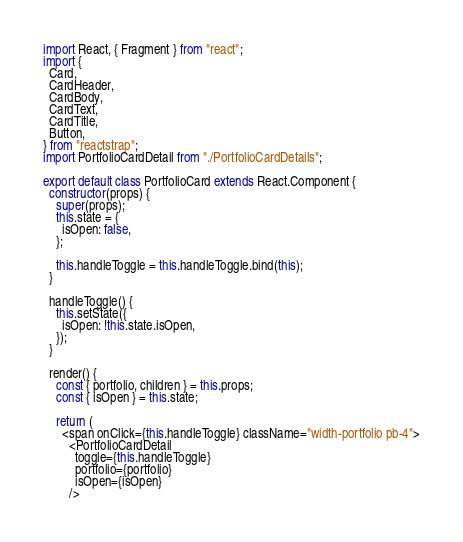<code> <loc_0><loc_0><loc_500><loc_500><_JavaScript_>import React, { Fragment } from "react";
import {
  Card,
  CardHeader,
  CardBody,
  CardText,
  CardTitle,
  Button,
} from "reactstrap";
import PortfolioCardDetail from "./PortfolioCardDetails";

export default class PortfolioCard extends React.Component {
  constructor(props) {
    super(props);
    this.state = {
      isOpen: false,
    };

    this.handleToggle = this.handleToggle.bind(this);
  }

  handleToggle() {
    this.setState({
      isOpen: !this.state.isOpen,
    });
  }

  render() {
    const { portfolio, children } = this.props;
    const { isOpen } = this.state;

    return (
      <span onClick={this.handleToggle} className="width-portfolio pb-4">
        <PortfolioCardDetail
          toggle={this.handleToggle}
          portfolio={portfolio}
          isOpen={isOpen}
        />
</code> 